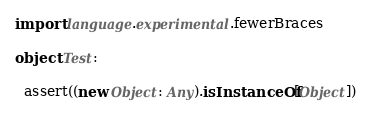Convert code to text. <code><loc_0><loc_0><loc_500><loc_500><_Scala_>import language.experimental.fewerBraces

object Test:

  assert((new Object: Any).isInstanceOf[Object])</code> 